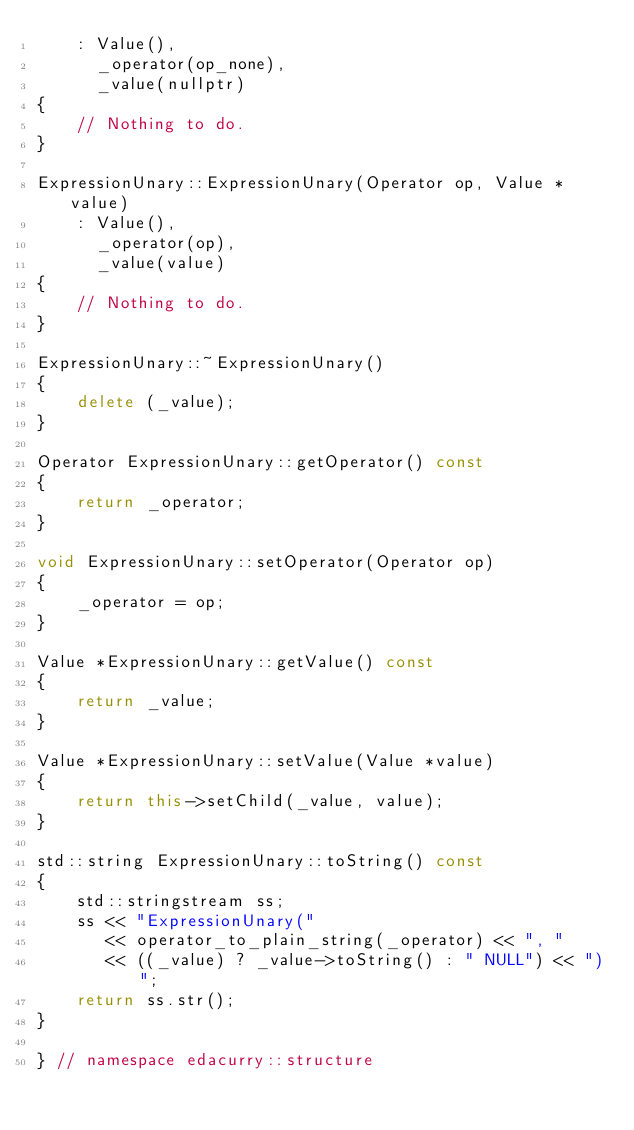<code> <loc_0><loc_0><loc_500><loc_500><_C++_>    : Value(),
      _operator(op_none),
      _value(nullptr)
{
    // Nothing to do.
}

ExpressionUnary::ExpressionUnary(Operator op, Value *value)
    : Value(),
      _operator(op),
      _value(value)
{
    // Nothing to do.
}

ExpressionUnary::~ExpressionUnary()
{
    delete (_value);
}

Operator ExpressionUnary::getOperator() const
{
    return _operator;
}

void ExpressionUnary::setOperator(Operator op)
{
    _operator = op;
}

Value *ExpressionUnary::getValue() const
{
    return _value;
}

Value *ExpressionUnary::setValue(Value *value)
{
    return this->setChild(_value, value);
}

std::string ExpressionUnary::toString() const
{
    std::stringstream ss;
    ss << "ExpressionUnary("
       << operator_to_plain_string(_operator) << ", "
       << ((_value) ? _value->toString() : " NULL") << ")";
    return ss.str();
}

} // namespace edacurry::structure</code> 